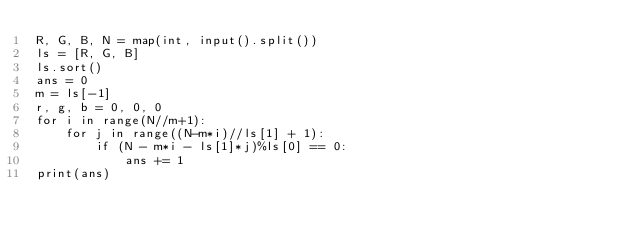Convert code to text. <code><loc_0><loc_0><loc_500><loc_500><_Python_>R, G, B, N = map(int, input().split())
ls = [R, G, B]
ls.sort()
ans = 0
m = ls[-1]
r, g, b = 0, 0, 0
for i in range(N//m+1):
    for j in range((N-m*i)//ls[1] + 1):
        if (N - m*i - ls[1]*j)%ls[0] == 0:
            ans += 1
print(ans)</code> 